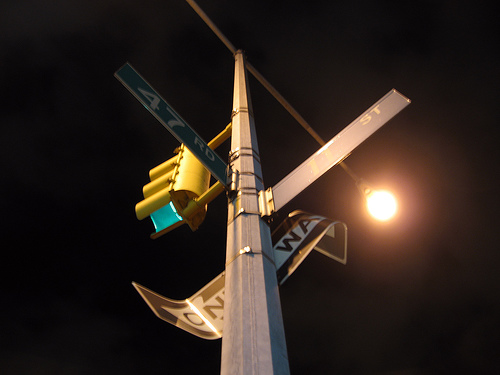Please transcribe the text information in this image. 47 RD WA ON 